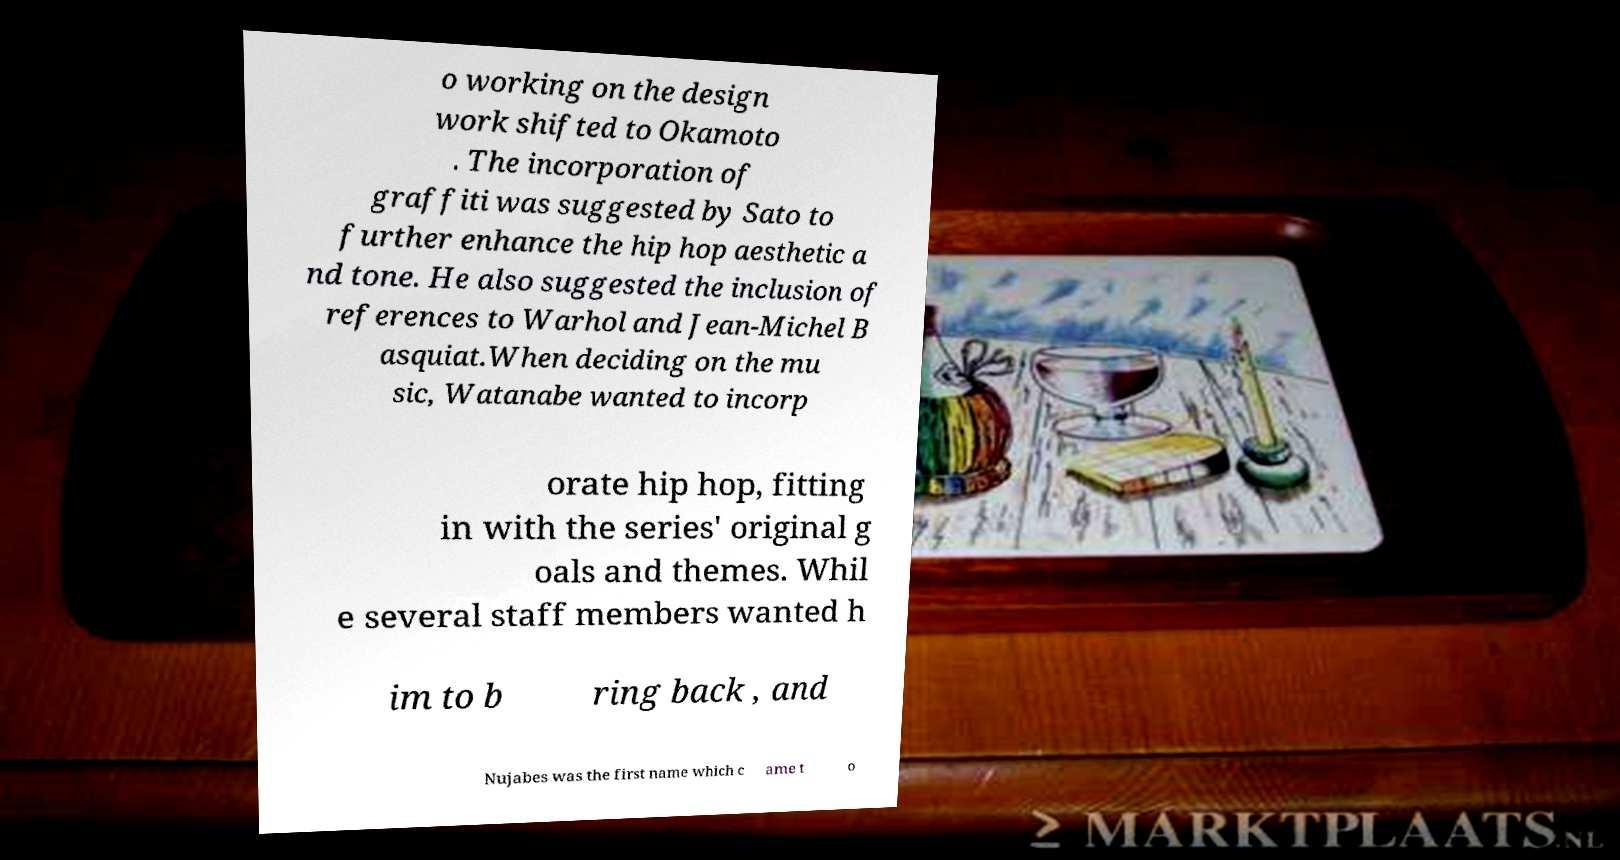There's text embedded in this image that I need extracted. Can you transcribe it verbatim? o working on the design work shifted to Okamoto . The incorporation of graffiti was suggested by Sato to further enhance the hip hop aesthetic a nd tone. He also suggested the inclusion of references to Warhol and Jean-Michel B asquiat.When deciding on the mu sic, Watanabe wanted to incorp orate hip hop, fitting in with the series' original g oals and themes. Whil e several staff members wanted h im to b ring back , and Nujabes was the first name which c ame t o 